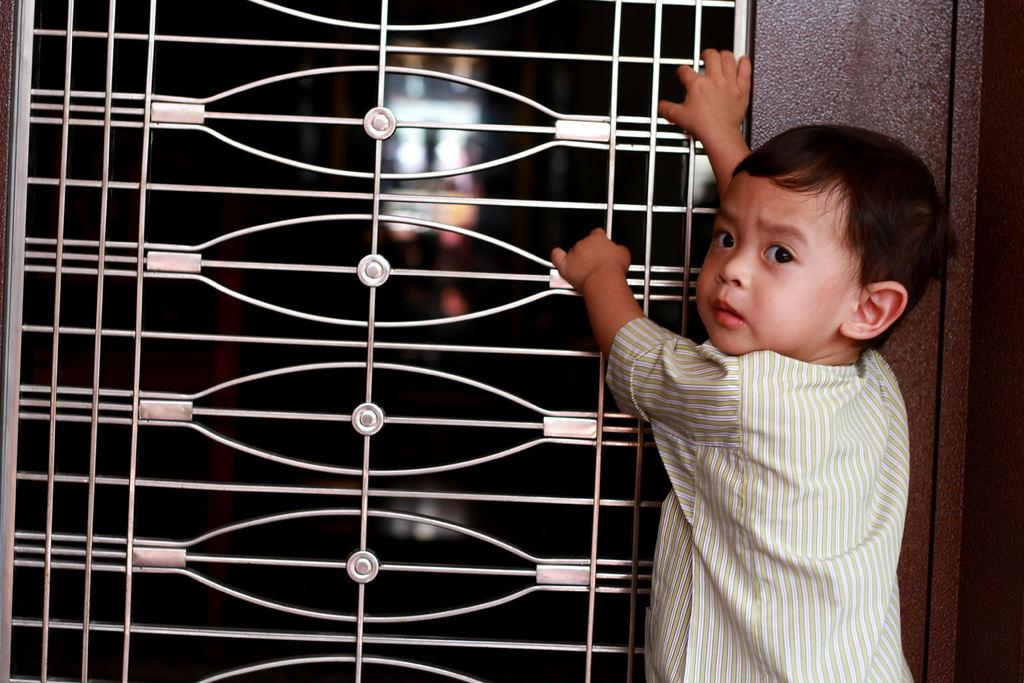What is the main subject of the image? There is a person in the image. What is the person doing in the image? The person is standing. What is the person wearing in the image? The person is wearing a white and green color dress. What is the person holding in the image? The person is holding the window grill. Can you describe the background of the image? The background of the image is blurred. What type of salt is the person using to season the dish in the image? There is no dish or salt present in the image; it only features a person holding a window grill. Is the person's grandmother in the image? There is no indication of the person's grandmother in the image. 